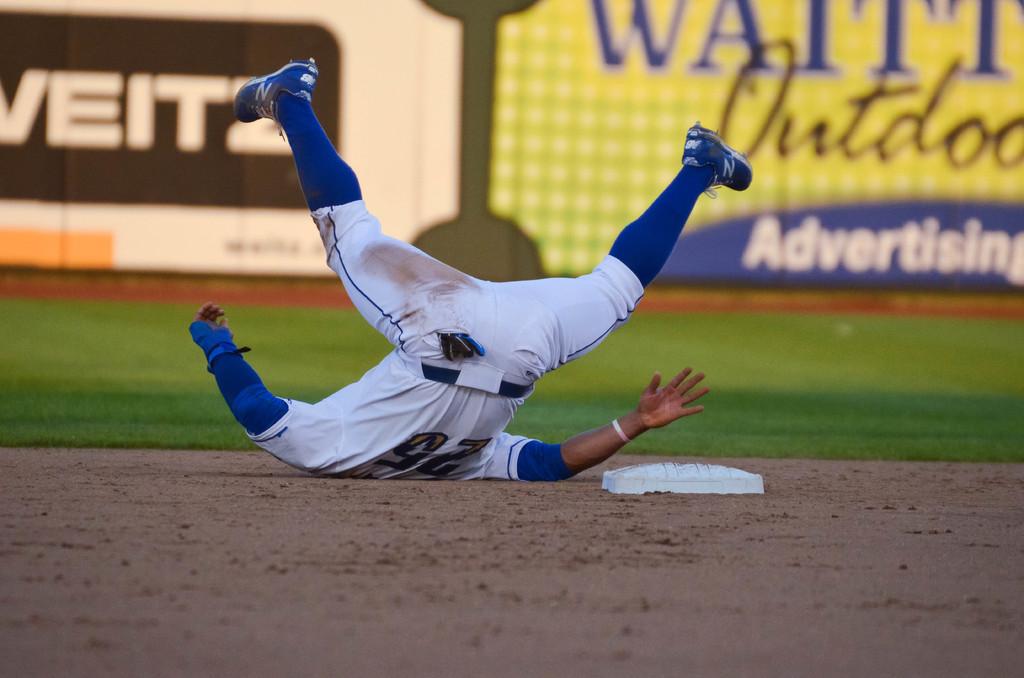What is the players number who fell?
Your answer should be very brief. 25. 